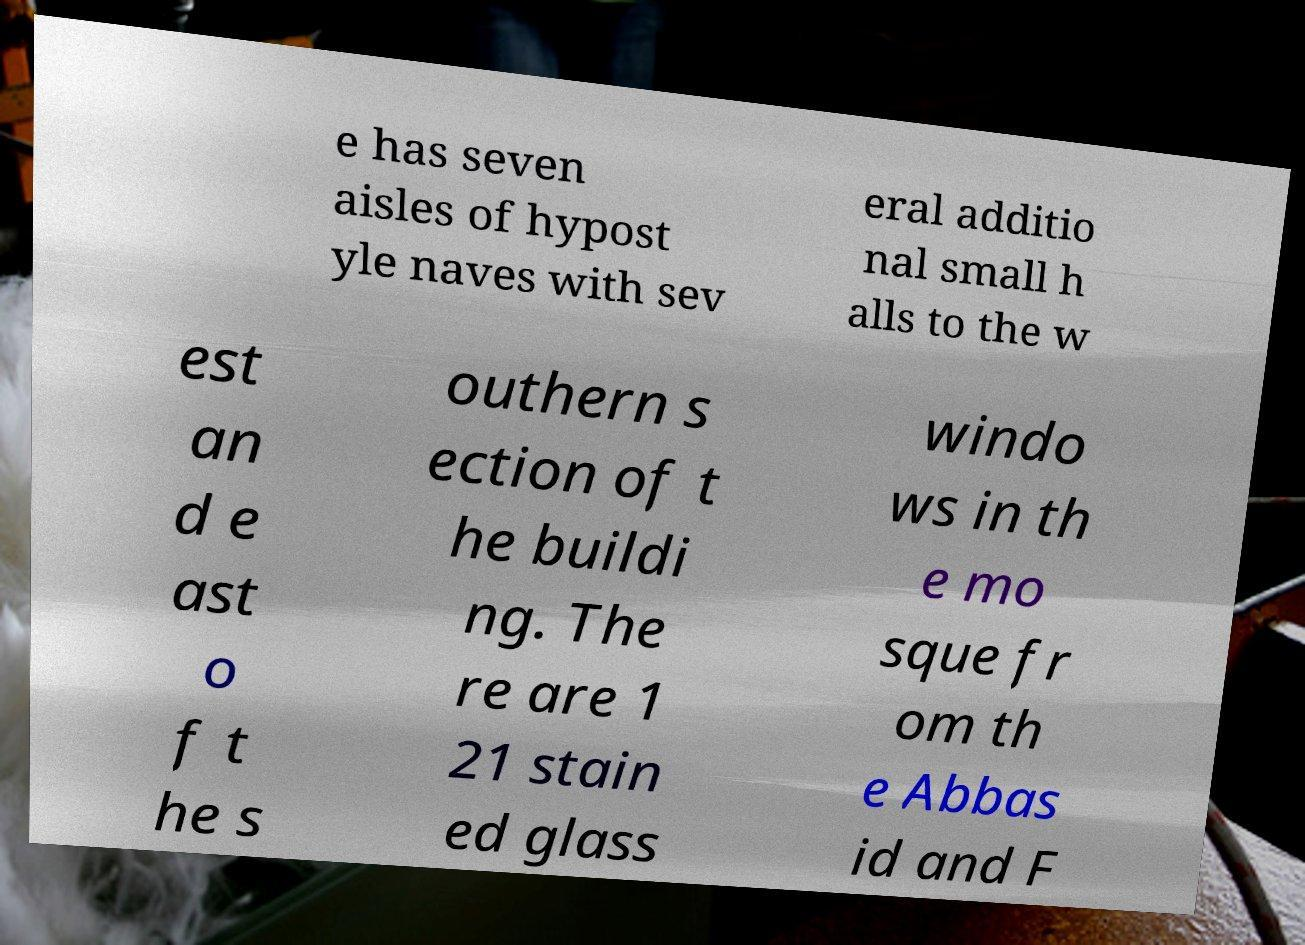Please read and relay the text visible in this image. What does it say? e has seven aisles of hypost yle naves with sev eral additio nal small h alls to the w est an d e ast o f t he s outhern s ection of t he buildi ng. The re are 1 21 stain ed glass windo ws in th e mo sque fr om th e Abbas id and F 